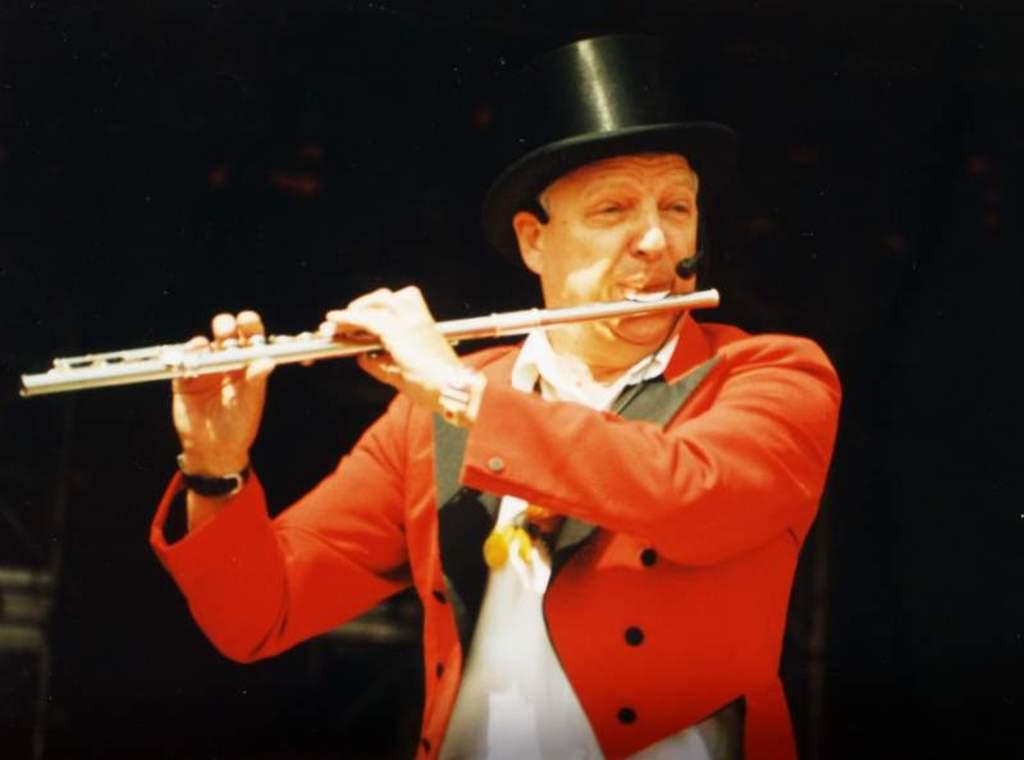What is the main subject of the image? There is a person in the image. What is the person wearing? The person is wearing an orange jacket. What is the person holding in the image? The person is holding a musical instrument. What is the person doing with the musical instrument? The person is playing the musical instrument. What is the position of the person in the image? The person is standing. How would you describe the background of the image? The background of the image is dark in color. What type of yoke is the person using to play the musical instrument in the image? There is no yoke present in the image, and the person is not using any yoke to play the musical instrument. 